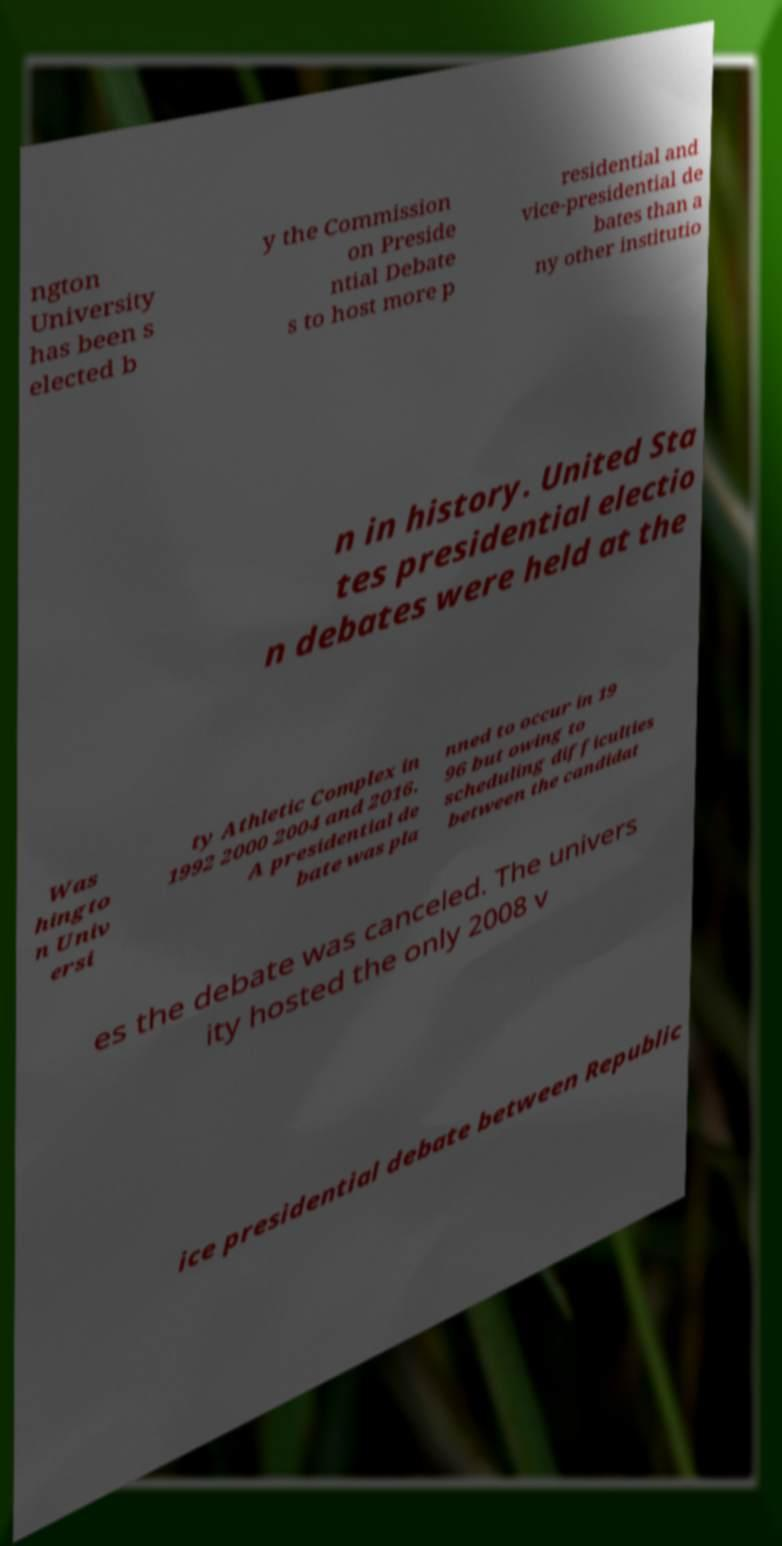Can you accurately transcribe the text from the provided image for me? ngton University has been s elected b y the Commission on Preside ntial Debate s to host more p residential and vice-presidential de bates than a ny other institutio n in history. United Sta tes presidential electio n debates were held at the Was hingto n Univ ersi ty Athletic Complex in 1992 2000 2004 and 2016. A presidential de bate was pla nned to occur in 19 96 but owing to scheduling difficulties between the candidat es the debate was canceled. The univers ity hosted the only 2008 v ice presidential debate between Republic 